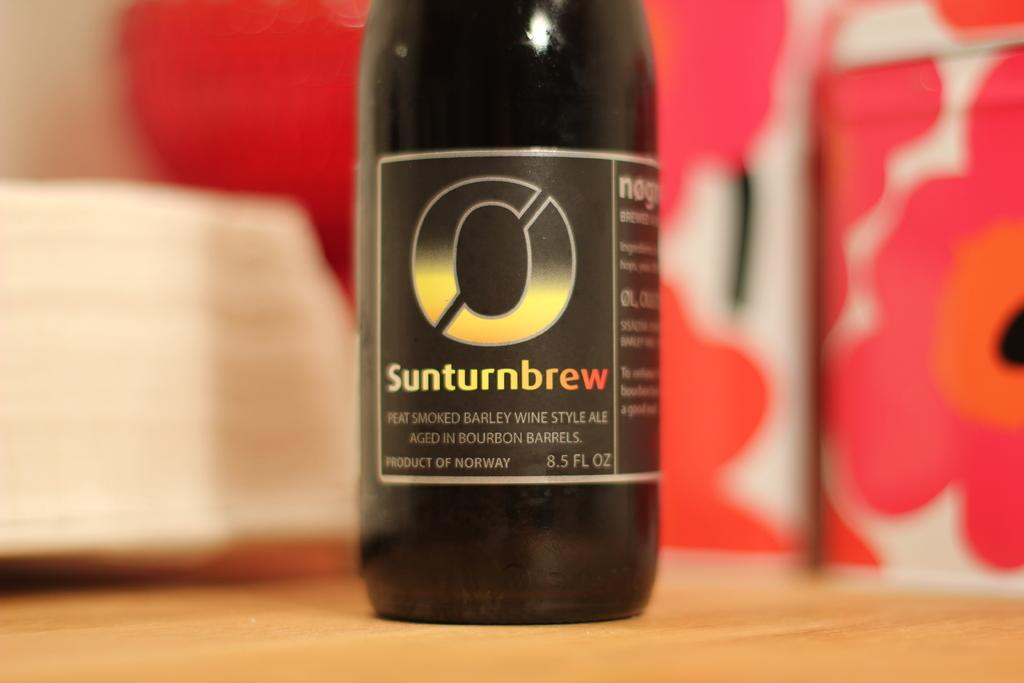What is present on the table in the image? There is a black color bottle on the table. What is written on the bottle? The bottle is labelled as "sunturnbrew". What can be seen in the background of the image? There is a pink color background in the image, and a plate is visible in the background. What type of vase is placed on the range in the image? There is no vase or range present in the image. How does the air circulate in the image? The image does not provide information about air circulation. 